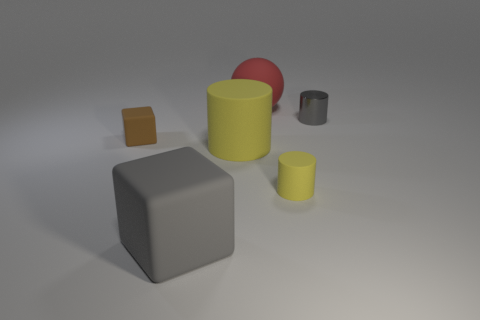Add 2 metallic things. How many objects exist? 8 Subtract all blocks. How many objects are left? 4 Add 6 cubes. How many cubes are left? 8 Add 5 large matte blocks. How many large matte blocks exist? 6 Subtract 0 red cylinders. How many objects are left? 6 Subtract all metallic things. Subtract all gray cubes. How many objects are left? 4 